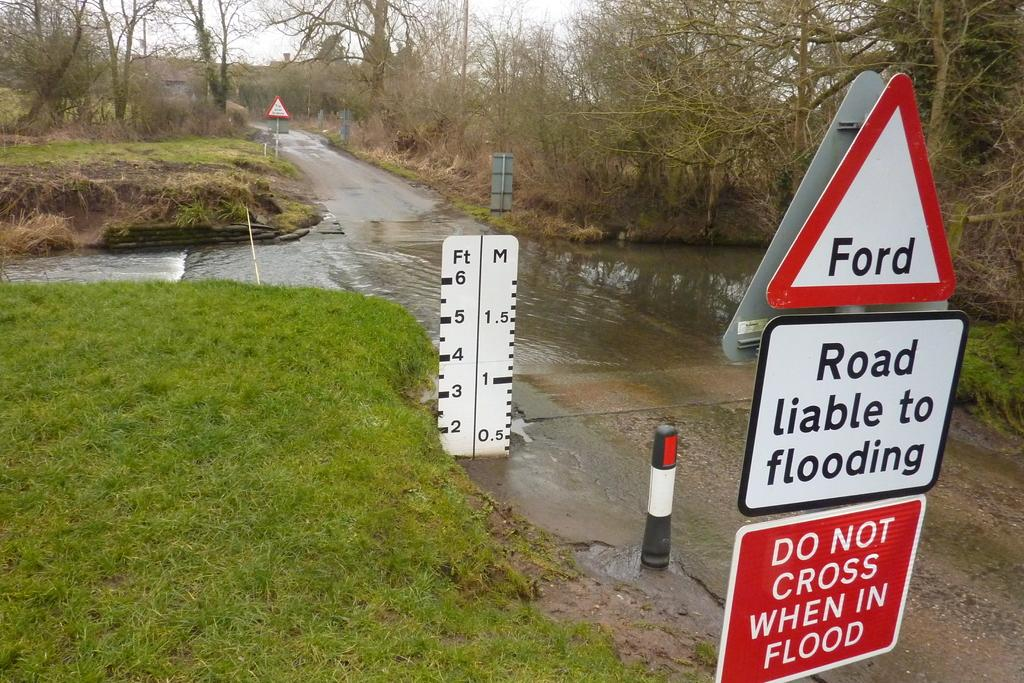<image>
Offer a succinct explanation of the picture presented. Road sign reading Road liable to flooding in front of an intersection that is flooded with water. 